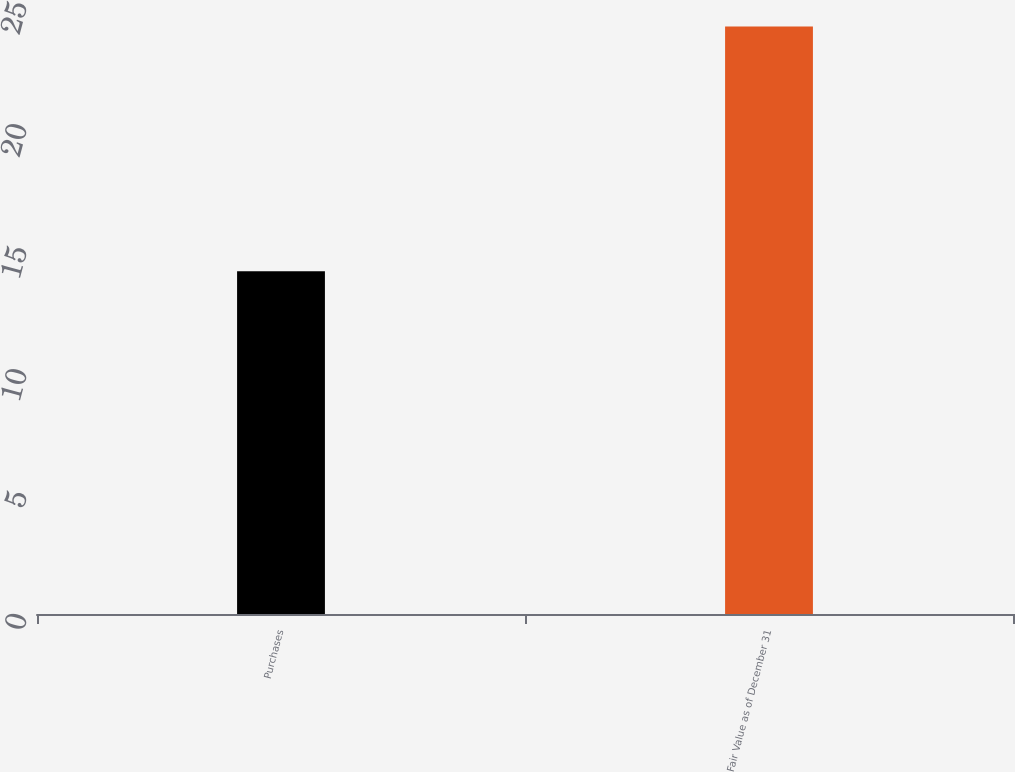Convert chart. <chart><loc_0><loc_0><loc_500><loc_500><bar_chart><fcel>Purchases<fcel>Fair Value as of December 31<nl><fcel>14<fcel>24<nl></chart> 